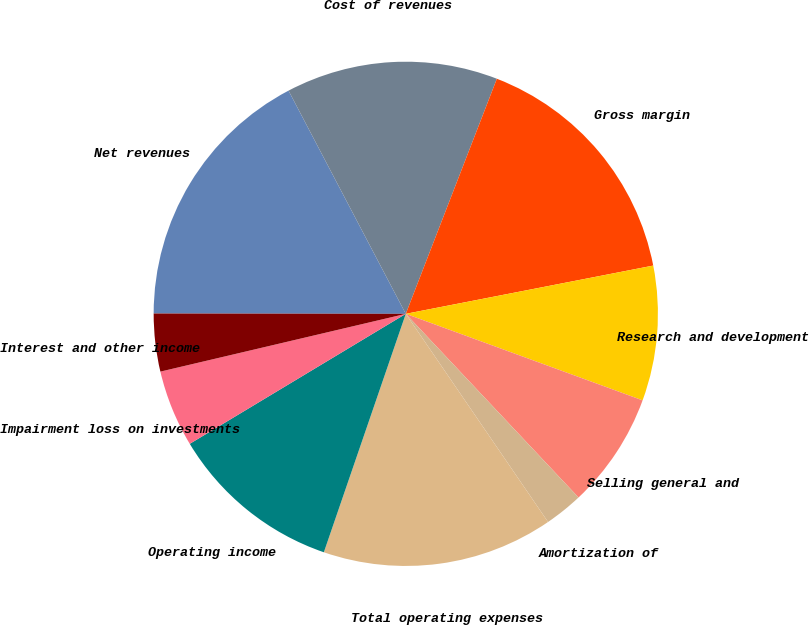Convert chart to OTSL. <chart><loc_0><loc_0><loc_500><loc_500><pie_chart><fcel>Net revenues<fcel>Cost of revenues<fcel>Gross margin<fcel>Research and development<fcel>Selling general and<fcel>Amortization of<fcel>Total operating expenses<fcel>Operating income<fcel>Impairment loss on investments<fcel>Interest and other income<nl><fcel>17.28%<fcel>13.58%<fcel>16.05%<fcel>8.64%<fcel>7.41%<fcel>2.47%<fcel>14.81%<fcel>11.11%<fcel>4.94%<fcel>3.7%<nl></chart> 